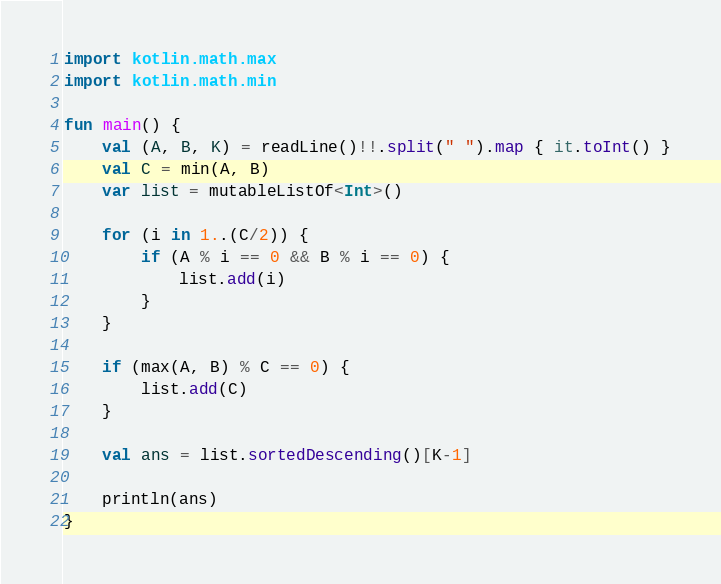<code> <loc_0><loc_0><loc_500><loc_500><_Kotlin_>import kotlin.math.max
import kotlin.math.min

fun main() {
    val (A, B, K) = readLine()!!.split(" ").map { it.toInt() }
    val C = min(A, B)
    var list = mutableListOf<Int>()

    for (i in 1..(C/2)) {
        if (A % i == 0 && B % i == 0) {
            list.add(i)
        }
    }

    if (max(A, B) % C == 0) {
        list.add(C)
    }

    val ans = list.sortedDescending()[K-1]

    println(ans)
}</code> 